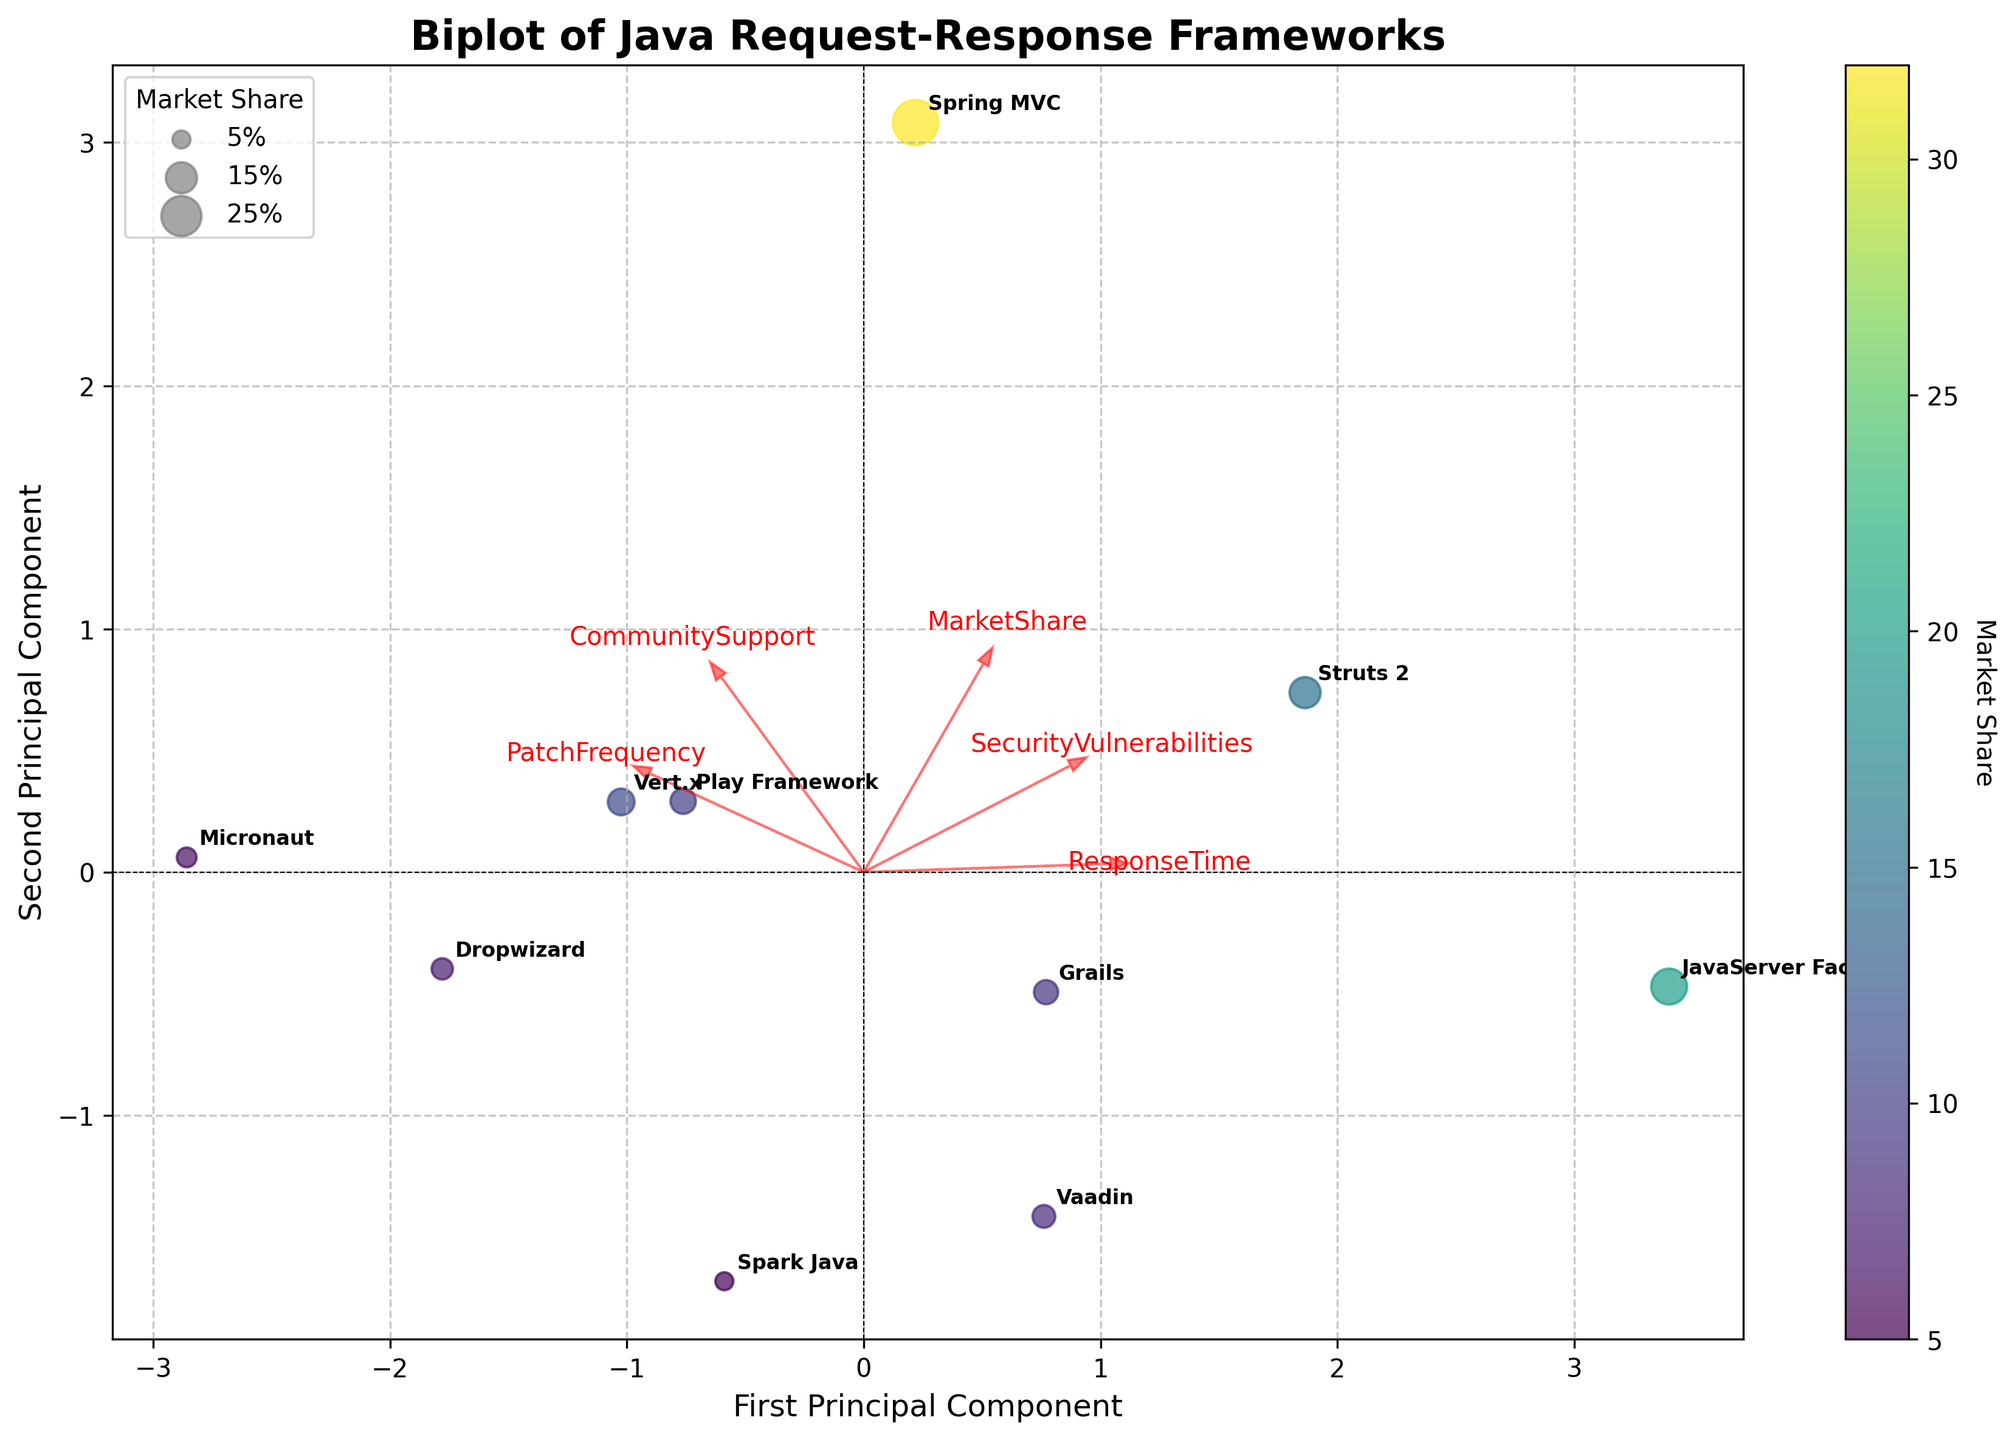Which framework has the highest Market Share? The color of the scatter points indicates the Market Share, with darker green representing higher Market Share. Spring MVC has the largest bubble, indicating it has the highest Market Share.
Answer: Spring MVC Which principal component explains more variability in the data? The x-axis represents the First Principal Component, and the y-axis represents the Second Principal Component. The longer axis typically indicates more explained variability.
Answer: First Principal Component What is the relationship between Patch Frequency and Market Share? The arrow representing Patch Frequency points towards the frameworks with larger bubbles, indicating that frameworks with higher Patch Frequency tend to have a larger Market Share.
Answer: Positive correlation Which framework appears closest to the origin in the biplot? The origin of the biplot is marked by (0,0). Vert.x appears closest to this point, indicating it has average values along both components.
Answer: Vert.x Between Security Vulnerabilities and Response Time, which factor has a stronger influence on the first principal component? The length and direction of the arrows indicate the influence of each factor on the principal components. Security Vulnerabilities is more aligned with the First Principal Component and has a longer arrow compared to Response Time.
Answer: Security Vulnerabilities Which framework has a higher Security Vulnerabilities, Play Framework or Grails? Look at the positions of Play Framework and Grails relative to the arrow representing Security Vulnerabilities. Grails is found further along this arrow.
Answer: Grails Is there any framework with both low Security Vulnerabilities and high Community Support? Micronaut is positioned towards the low end of the Security Vulnerabilities arrow and high along the Community Support axis.
Answer: Micronaut What trends can be inferred about frameworks with high Community Support? Frameworks such as Micronaut and Vert.x, with high Community Support, are associated with low Response Time and high Patch Frequency, as indicated by their position relative to the related arrows.
Answer: High support correlates with low response time & high patch frequency Which framework has the lowest Patch Frequency? The framework closest to the origin along the arrow representing Patch Frequency marks the lowest value. JavaServer Faces is closest to this.
Answer: JavaServer Faces 